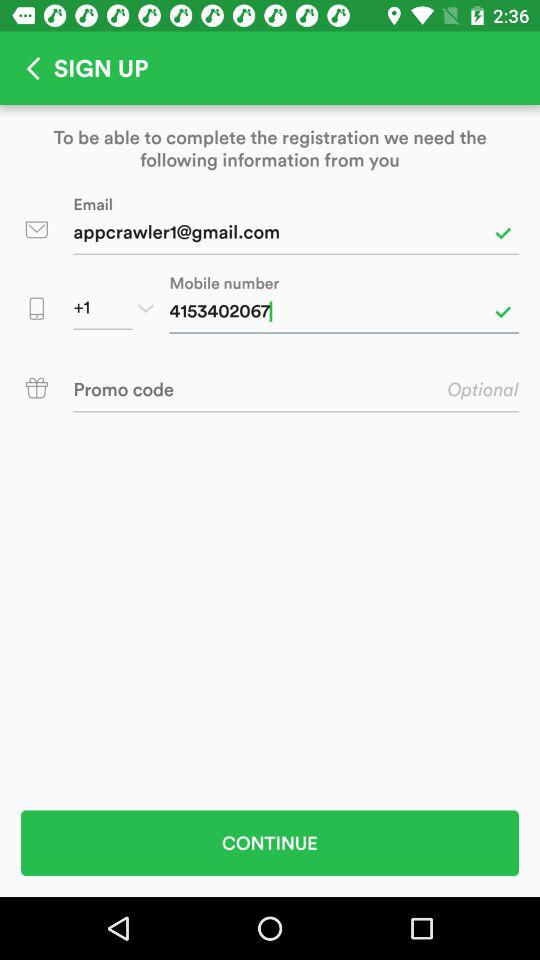How many text fields are there in this form?
Answer the question using a single word or phrase. 3 